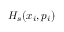Convert formula to latex. <formula><loc_0><loc_0><loc_500><loc_500>H _ { s } ( x _ { i } , p _ { i } )</formula> 